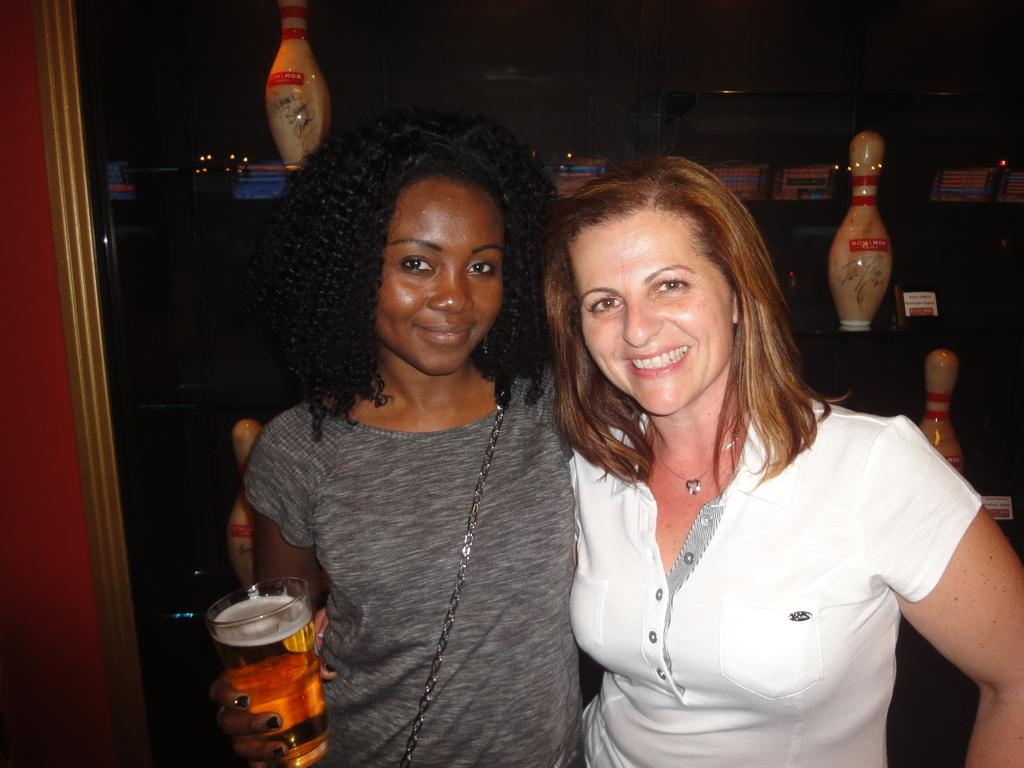How many women are in the image? There are two women in the image. What expressions do the women have? Both women are smiling. What is one of the women holding in her hands? One woman is holding a glass with a drink in her hands. What can be seen in the background of the image? There are bottles visible in the background of the image. What type of airport can be seen in the image? There is no airport present in the image. What does the cub do with the rub in the image? There is no cub or rub present in the image. 